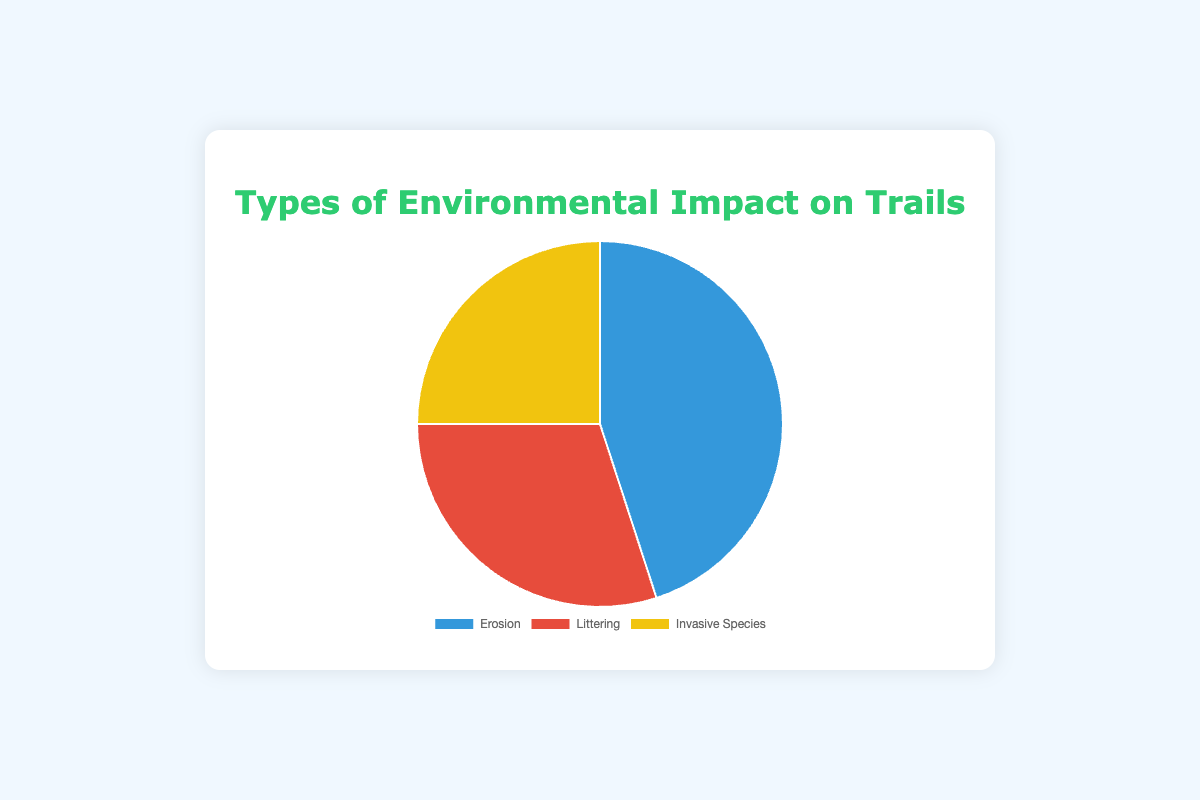Which type of environmental impact is the most significant on trails? The segment with the highest percentage indicates the most significant impact. Reviewing the figure, Erosion has the largest portion at 45%.
Answer: Erosion Which type of environmental impact covers 30% of the total impact? By examining the percentages, the segment that represents 30% is labeled "Littering."
Answer: Littering How much more significant is Erosion compared to Invasive Species in percentage points? Subtract the percentage of Invasive Species (25%) from Erosion (45%). (45% - 25%)
Answer: 20 percentage points What is the total percentage of environmental impact caused by Littering and Invasive Species combined? Add the percentages of Littering (30%) and Invasive Species (25%). (30% + 25%)
Answer: 55% What is the average percentage of impact per category? Calculate the average by summing the percentages of all three categories and then dividing by 3. ((45% + 30% + 25%) / 3)
Answer: 33.33% Is the percentage of Invasive Species and Littering combined greater than the percentage of Erosion? Compare the sum of the percentages of Invasive Species (25%) and Littering (30%) to Erosion (45%). (25% + 30% = 55%, which is greater than 45%)
Answer: Yes What color represents Littering in the pie chart? Identify the segment colored red, which corresponds to Littering.
Answer: Red Which two types of impact combined equal more than 70% of the total impact? Sum the percentages of each combination and see which pair exceeds 70%. Erosion (45%) + Littering (30%) = 75%.
Answer: Erosion and Littering If Invasive Species impact increased by 10 percentage points, what would the new percentage be? Add 10 percentage points to the current percentage of Invasive Species (25%). (25% + 10%)
Answer: 35% 